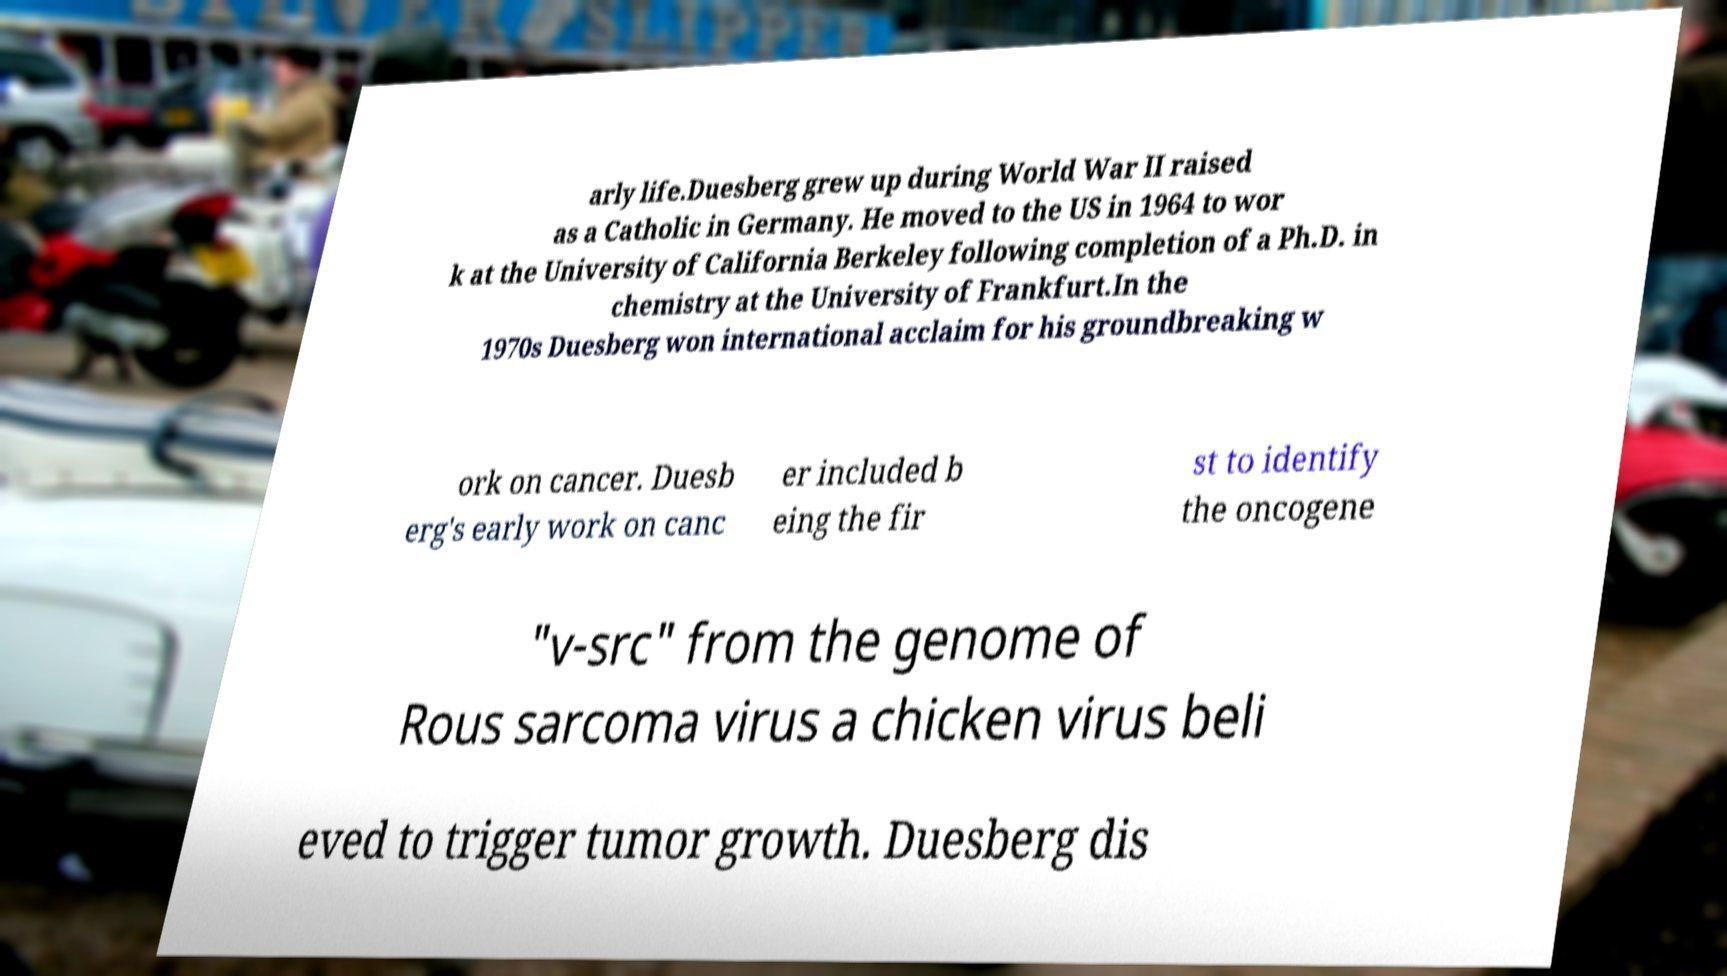Please identify and transcribe the text found in this image. arly life.Duesberg grew up during World War II raised as a Catholic in Germany. He moved to the US in 1964 to wor k at the University of California Berkeley following completion of a Ph.D. in chemistry at the University of Frankfurt.In the 1970s Duesberg won international acclaim for his groundbreaking w ork on cancer. Duesb erg's early work on canc er included b eing the fir st to identify the oncogene "v-src" from the genome of Rous sarcoma virus a chicken virus beli eved to trigger tumor growth. Duesberg dis 